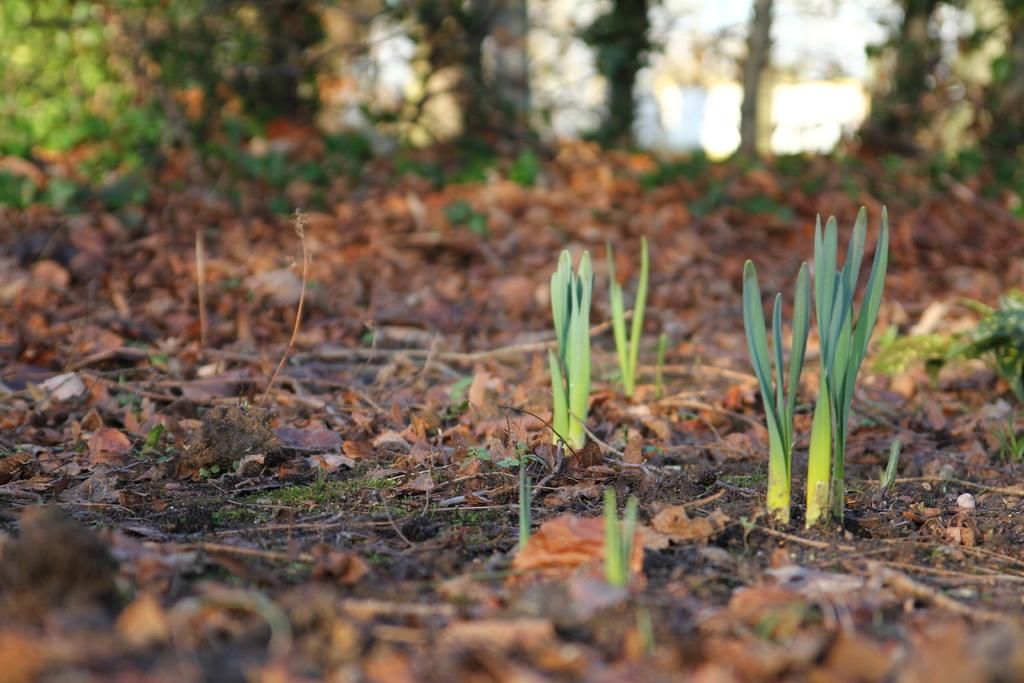What type of living organisms can be seen in the image? Plants are visible in the image. What can be found on the ground in the image? Leaves and sticks are on the ground in the image. What is the condition of the background in the image? The background of the image is blurred. What celestial bodies are visible in the background of the image? Planets are visible in the background of the image. What part of the natural environment is visible in the image? The sky is visible in the background of the image. What type of soda can be seen being poured on the plants in the image? There is no soda present in the image; it features plants, leaves, and sticks on the ground. How many snails can be seen crawling on the leaves in the image? There are no snails present in the image; it only features plants, leaves, and sticks on the ground. 